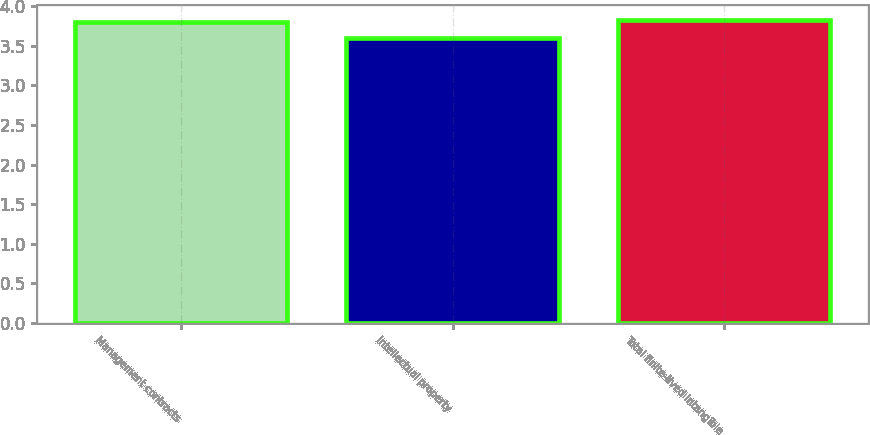Convert chart to OTSL. <chart><loc_0><loc_0><loc_500><loc_500><bar_chart><fcel>Management contracts<fcel>Intellectual property<fcel>Total finite-lived intangible<nl><fcel>3.8<fcel>3.6<fcel>3.82<nl></chart> 